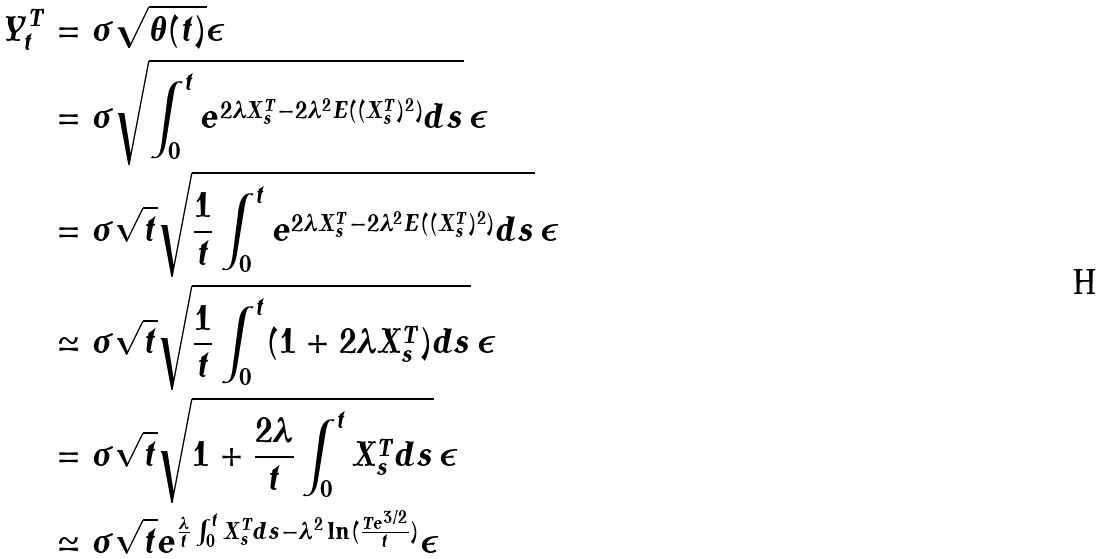Convert formula to latex. <formula><loc_0><loc_0><loc_500><loc_500>Y _ { t } ^ { T } & = \sigma \sqrt { \theta ( t ) } \epsilon \\ & = \sigma \sqrt { \int _ { 0 } ^ { t } e ^ { 2 \lambda X _ { s } ^ { T } - 2 \lambda ^ { 2 } E ( ( X _ { s } ^ { T } ) ^ { 2 } ) } d s } \, \epsilon \\ & = \sigma \sqrt { t } \sqrt { \frac { 1 } { t } \int _ { 0 } ^ { t } e ^ { 2 \lambda X _ { s } ^ { T } - 2 \lambda ^ { 2 } E ( ( X _ { s } ^ { T } ) ^ { 2 } ) } d s } \, \epsilon \\ & \simeq \sigma \sqrt { t } \sqrt { \frac { 1 } { t } \int _ { 0 } ^ { t } ( 1 + 2 \lambda X _ { s } ^ { T } ) d s } \, \epsilon \\ & = \sigma \sqrt { t } \sqrt { 1 + \frac { 2 \lambda } { t } \int _ { 0 } ^ { t } X _ { s } ^ { T } d s } \, \epsilon \\ & \simeq \sigma \sqrt { t } e ^ { \frac { \lambda } { t } \int _ { 0 } ^ { t } X _ { s } ^ { T } d s - \lambda ^ { 2 } \ln ( \frac { T e ^ { 3 / 2 } } { t } ) } \epsilon</formula> 